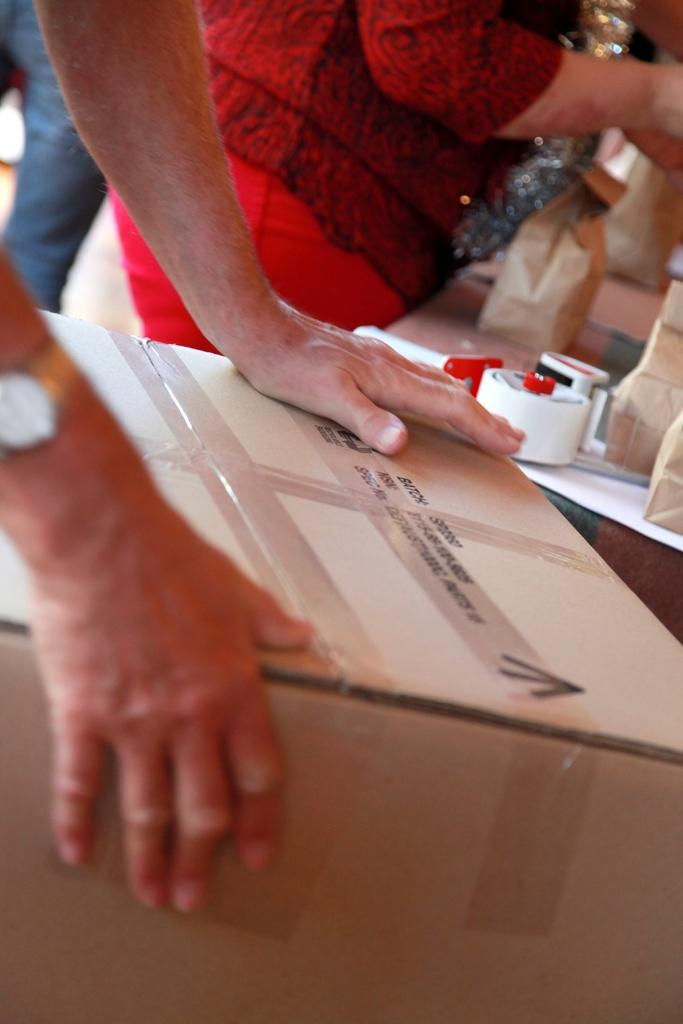What is the person holding in the image? The person is holding a cardboard box in the image. What is the woman doing in the image? The woman is standing near a table in the image. What items can be seen on the table? The table contains paper bags and plasters. How many bricks are stacked on the table in the image? There are no bricks present on the table in the image. Can you describe the flock of birds flying in the background of the image? There is no flock of birds visible in the background of the image. 